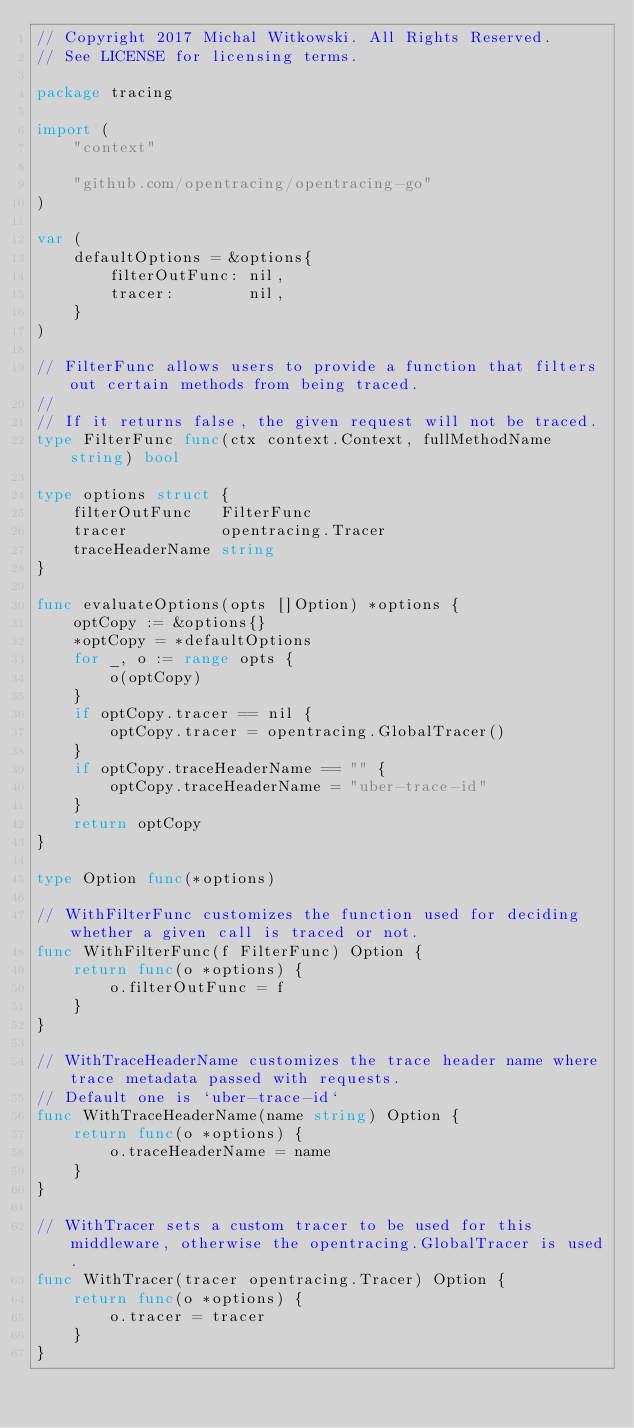Convert code to text. <code><loc_0><loc_0><loc_500><loc_500><_Go_>// Copyright 2017 Michal Witkowski. All Rights Reserved.
// See LICENSE for licensing terms.

package tracing

import (
	"context"

	"github.com/opentracing/opentracing-go"
)

var (
	defaultOptions = &options{
		filterOutFunc: nil,
		tracer:        nil,
	}
)

// FilterFunc allows users to provide a function that filters out certain methods from being traced.
//
// If it returns false, the given request will not be traced.
type FilterFunc func(ctx context.Context, fullMethodName string) bool

type options struct {
	filterOutFunc   FilterFunc
	tracer          opentracing.Tracer
	traceHeaderName string
}

func evaluateOptions(opts []Option) *options {
	optCopy := &options{}
	*optCopy = *defaultOptions
	for _, o := range opts {
		o(optCopy)
	}
	if optCopy.tracer == nil {
		optCopy.tracer = opentracing.GlobalTracer()
	}
	if optCopy.traceHeaderName == "" {
		optCopy.traceHeaderName = "uber-trace-id"
	}
	return optCopy
}

type Option func(*options)

// WithFilterFunc customizes the function used for deciding whether a given call is traced or not.
func WithFilterFunc(f FilterFunc) Option {
	return func(o *options) {
		o.filterOutFunc = f
	}
}

// WithTraceHeaderName customizes the trace header name where trace metadata passed with requests.
// Default one is `uber-trace-id`
func WithTraceHeaderName(name string) Option {
	return func(o *options) {
		o.traceHeaderName = name
	}
}

// WithTracer sets a custom tracer to be used for this middleware, otherwise the opentracing.GlobalTracer is used.
func WithTracer(tracer opentracing.Tracer) Option {
	return func(o *options) {
		o.tracer = tracer
	}
}
</code> 